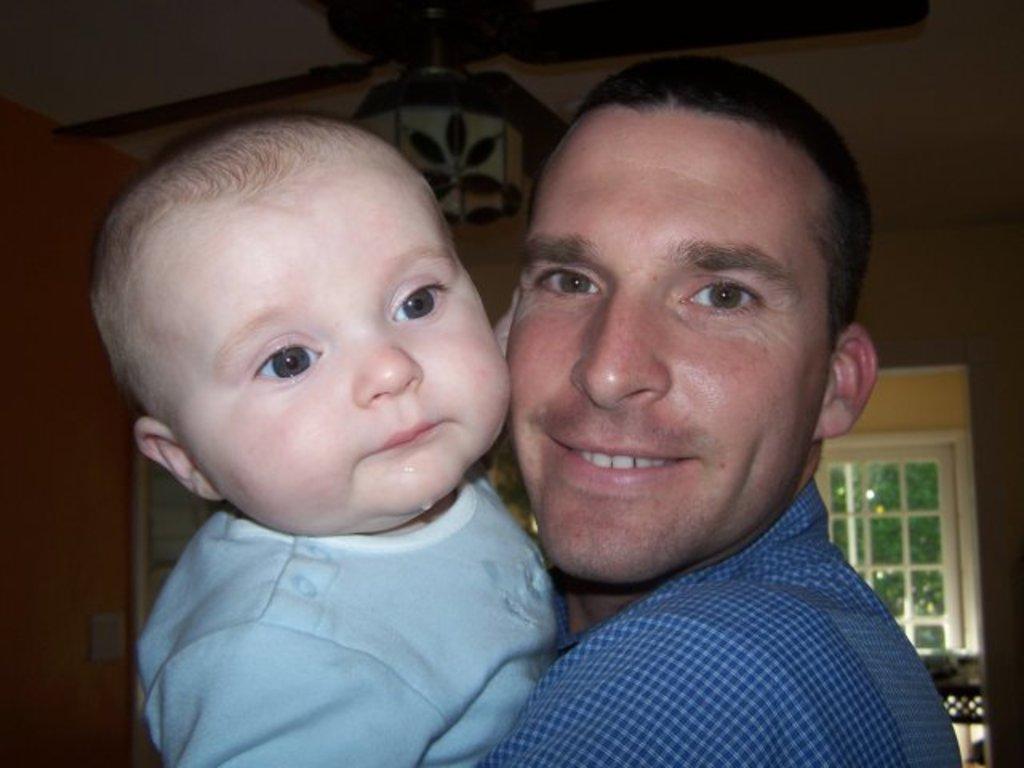Describe this image in one or two sentences. In this image we can see a man holding a baby in the background there is a window and a fan attached to the roof. 